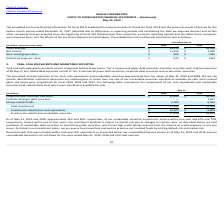According to Oracle Corporation's financial document, What does the unaudited pro forma financial information summarize? Based on the financial document, the answer is The unaudited pro forma financial information in the table below summarizes the combined results of operations for Oracle, Aconex and certain other companies that we acquired since the beginning of fiscal 2018 that were considered relevant for the purposes of unaudited pro forma financial information disclosure as if the companies were combined as of the beginning of fiscal 2018.. Also, How much was the total revenue in 2019? According to the financial document, 39,512 (in millions). The relevant text states: "Total revenues $ 39,512 $ 39,546..." Also, How much were the basic earnings per share in 2018? According to the financial document, $0.85. The relevant text states: "Basic earnings per share $ 3.05 $ 0.85..." Also, can you calculate: What was the average basic earnings per share over a 2 year period from 2018 to 2019? To answer this question, I need to perform calculations using the financial data. The calculation is: (3.05+0.85)/2 , which equals 1.95. This is based on the information: "Basic earnings per share $ 3.05 $ 0.85 Basic earnings per share $ 3.05 $ 0.85..." The key data points involved are: 0.85, 3.05. Also, can you calculate: What was the average total revenue over a 2 year period from 2018 to 2019? To answer this question, I need to perform calculations using the financial data. The calculation is: (39,512+ 39,546)/2 , which equals 39529 (in millions). This is based on the information: "Total revenues $ 39,512 $ 39,546 Total revenues $ 39,512 $ 39,546..." The key data points involved are: 39,512, 39,546. Also, can you calculate: What was the average diluted earnings per share over a 2 year period from 2018 to 2019? To answer this question, I need to perform calculations using the financial data. The calculation is: (0.83+2.97)/2, which equals 1.9. This is based on the information: "Diluted earnings per share $ 2.97 $ 0.83 Diluted earnings per share $ 2.97 $ 0.83..." The key data points involved are: 0.83, 2.97. 